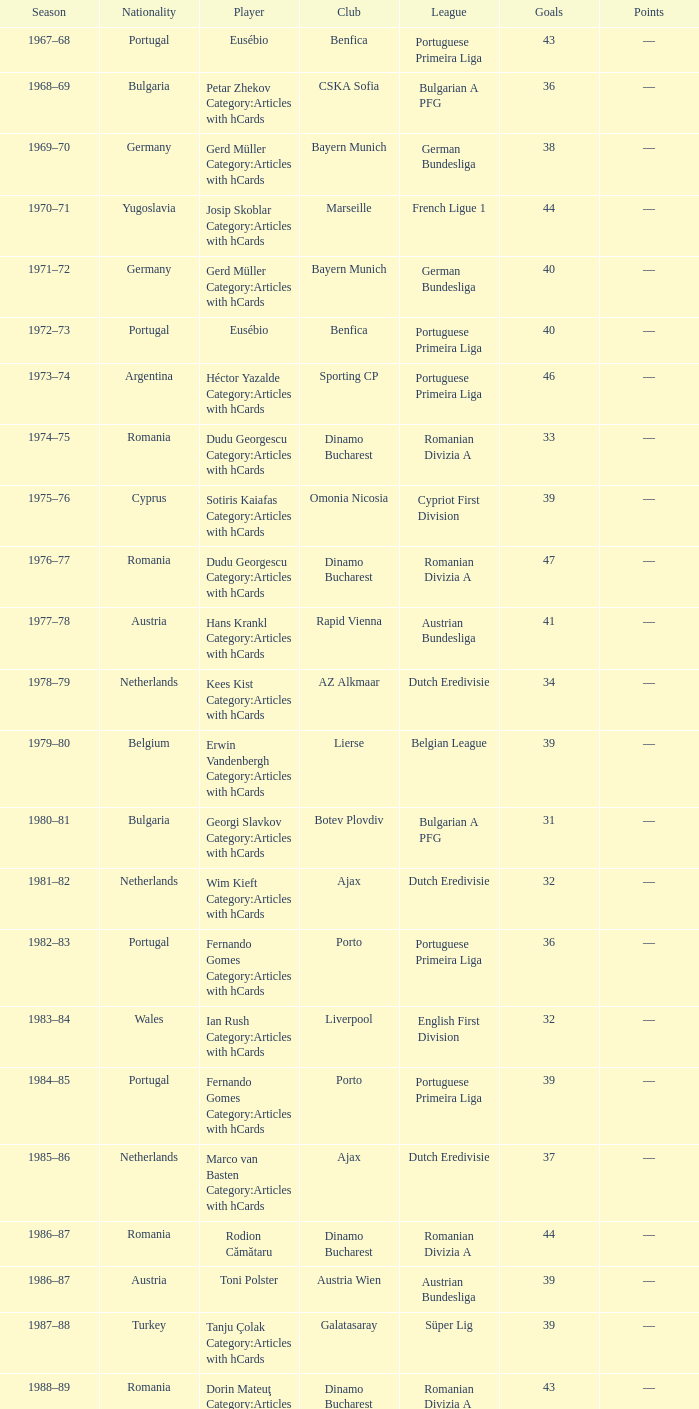Which league had italy as its nationality when the points totaled 62? Italian Serie A. 